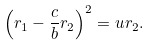<formula> <loc_0><loc_0><loc_500><loc_500>\left ( r _ { 1 } - \frac { c } { b } r _ { 2 } \right ) ^ { 2 } = u r _ { 2 } .</formula> 